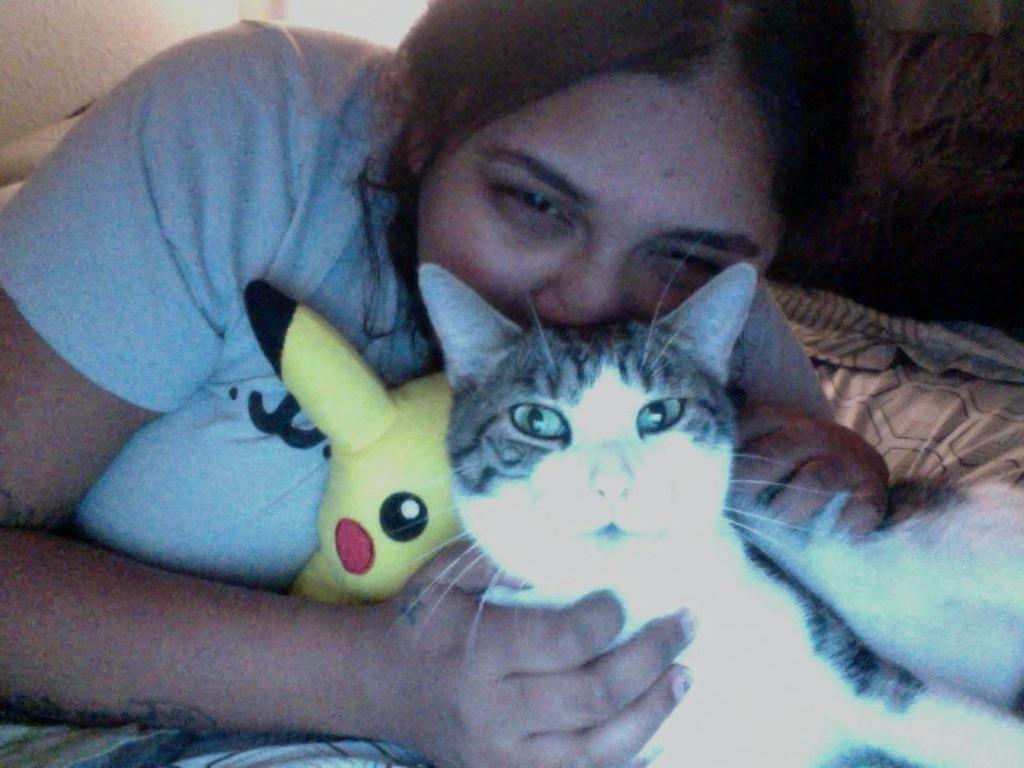Can you describe this image briefly? A woman is holding cat and toy in her hand and she is on the bed. 